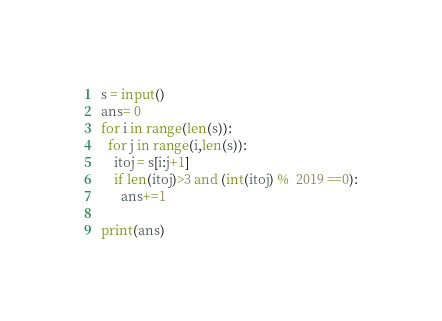<code> <loc_0><loc_0><loc_500><loc_500><_Python_>s = input()
ans= 0
for i in range(len(s)):
  for j in range(i,len(s)):
    itoj = s[i:j+1]
    if len(itoj)>3 and (int(itoj) %  2019 ==0):
      ans+=1

print(ans)</code> 